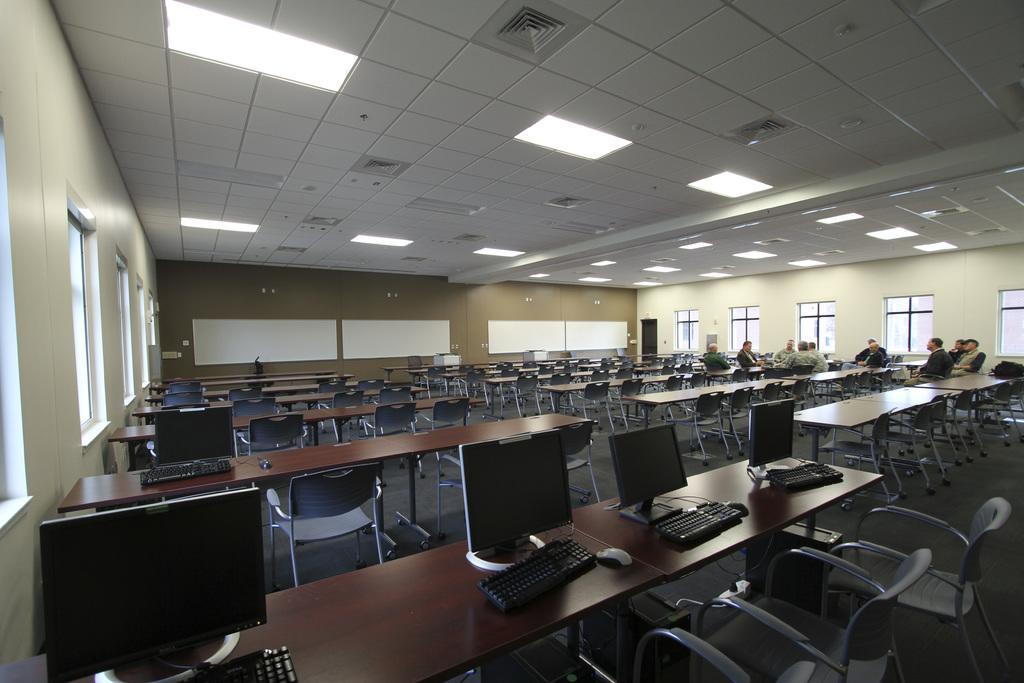In one or two sentences, can you explain what this image depicts? In this image there are many tables and many chairs placed on the floor. We can see many systems along with the keyboard on the table. There are few people sitting in the background of the image. This is the ceiling with lights. 